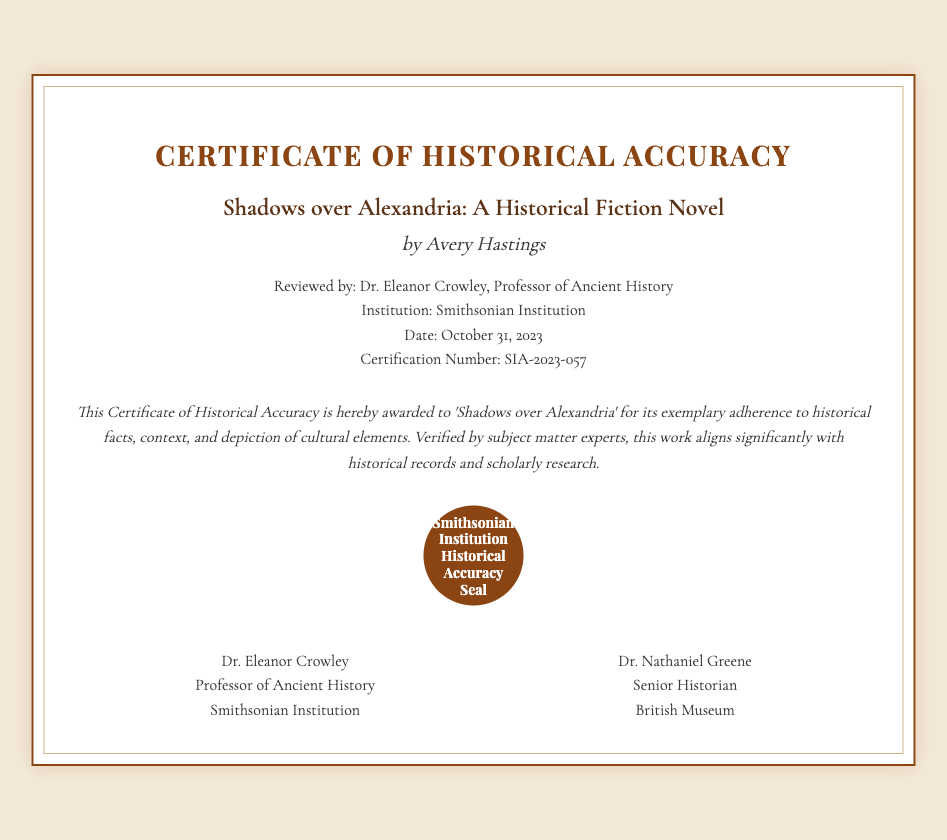What is the title of the novel? The title is mentioned in the document and is highlighted in a bold format.
Answer: Shadows over Alexandria Who is the author of the novel? The author's name is presented prominently in the document following the title.
Answer: Avery Hastings What is the date of certification? This information is listed in the details section of the document.
Answer: October 31, 2023 Who reviewed the manuscript? The reviewer's name appears in the details section, indicating the person who assessed the manuscript.
Answer: Dr. Eleanor Crowley What is the certification number? The certification number is specifically mentioned in the details section of the document.
Answer: SIA-2023-057 What institution awarded the certificate? This information is provided in the details section and indicates the organization responsible for the certification.
Answer: Smithsonian Institution What does the statement emphasize about the novel? The statement provides a summary regarding the historical accuracy acknowledged in the document.
Answer: Exemplary adherence to historical facts Which two professionals signed the certificate? The document lists two individuals under the signatories section who confirmed the historical accuracy.
Answer: Dr. Eleanor Crowley and Dr. Nathaniel Greene What type of seal is included on the certificate? The seal is described at the bottom of the document, indicating its purpose.
Answer: Smithsonian Institution Historical Accuracy Seal 